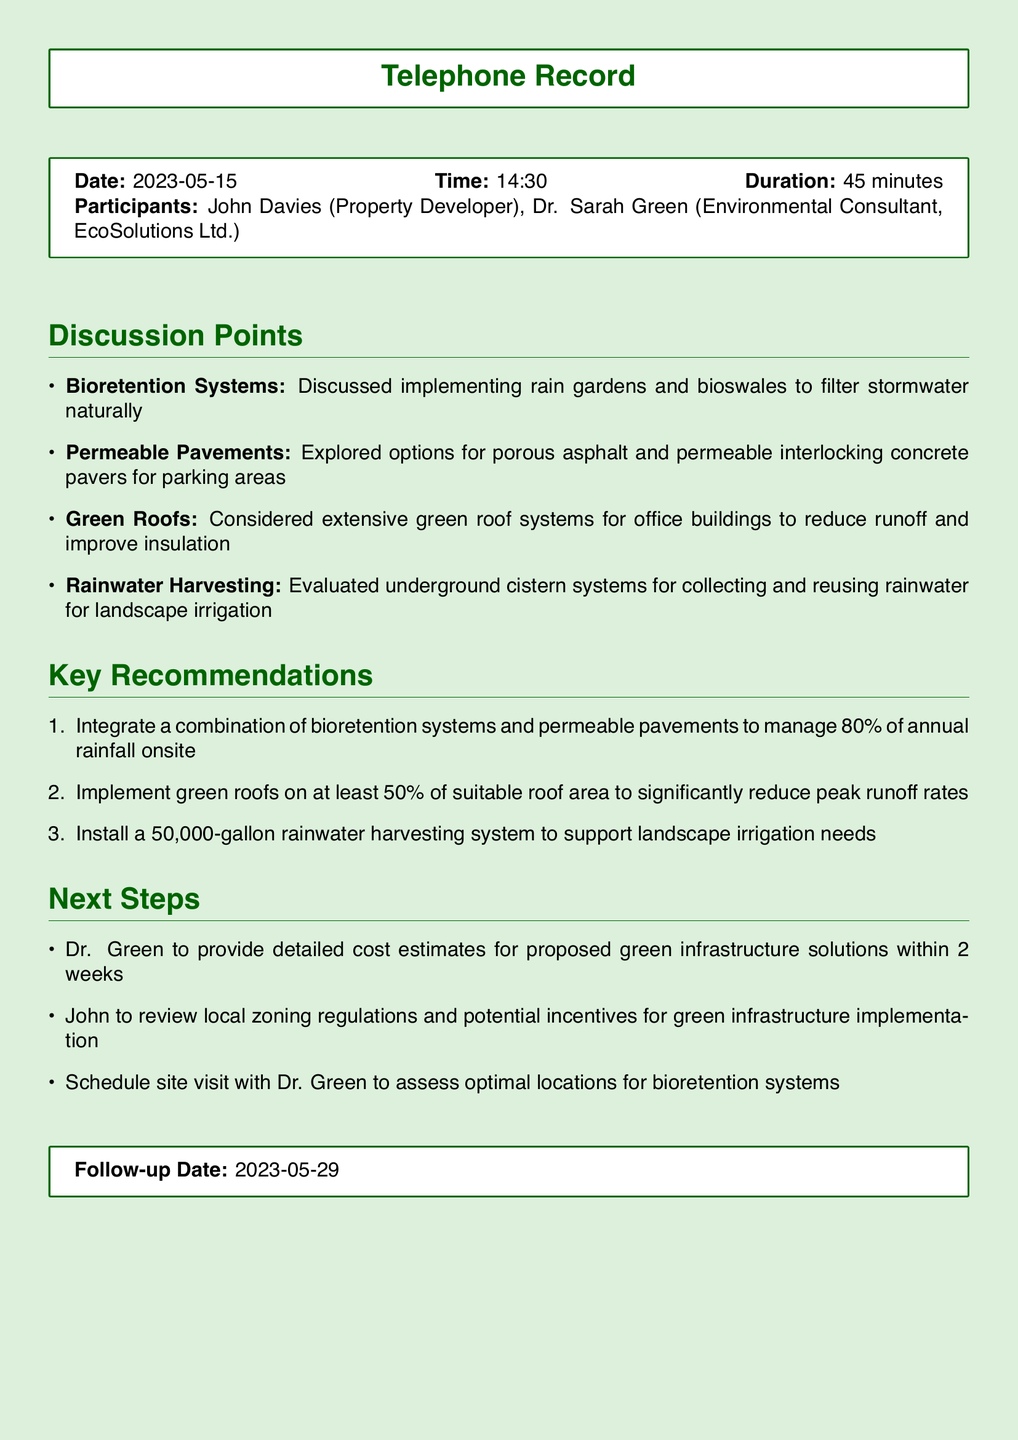what is the date of the telephone call? The date of the telephone call is mentioned at the beginning of the record.
Answer: 2023-05-15 who are the participants in the call? The participants' names and roles are listed under the telephone record details.
Answer: John Davies, Dr. Sarah Green what was the duration of the call? The duration is specified as part of the telephone record details.
Answer: 45 minutes what percentage of the roof area should be covered with green roofs according to recommendations? The recommendation specifies the percentage of suitable roof area to be covered under key recommendations.
Answer: 50% what type of systems were discussed for natural stormwater filtering? The document lists various practices discussed to manage stormwater.
Answer: Bioretention Systems how many gallons is the suggested rainwater harvesting system? The specific capacity of the rainwater harvesting system is provided in the key recommendations section.
Answer: 50,000 gallons what is the follow-up date for the next steps? The follow-up date is clearly stated at the end of the document.
Answer: 2023-05-29 what is one of the next steps mentioned for Dr. Green? The next steps include specific actions for Dr. Green to take after the call.
Answer: Provide detailed cost estimates how much annual rainfall is to be managed onsite according to the recommendations? The document indicates a target for managing rainfall onsite within the key recommendations.
Answer: 80% 